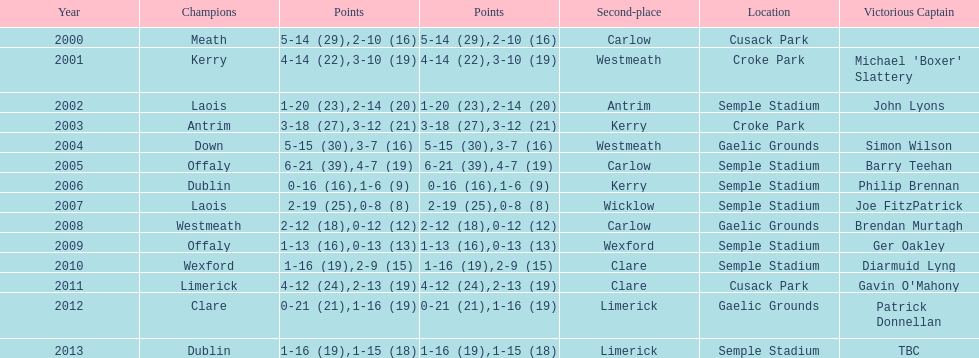Who was the winning captain the last time the competition was held at the gaelic grounds venue? Patrick Donnellan. 